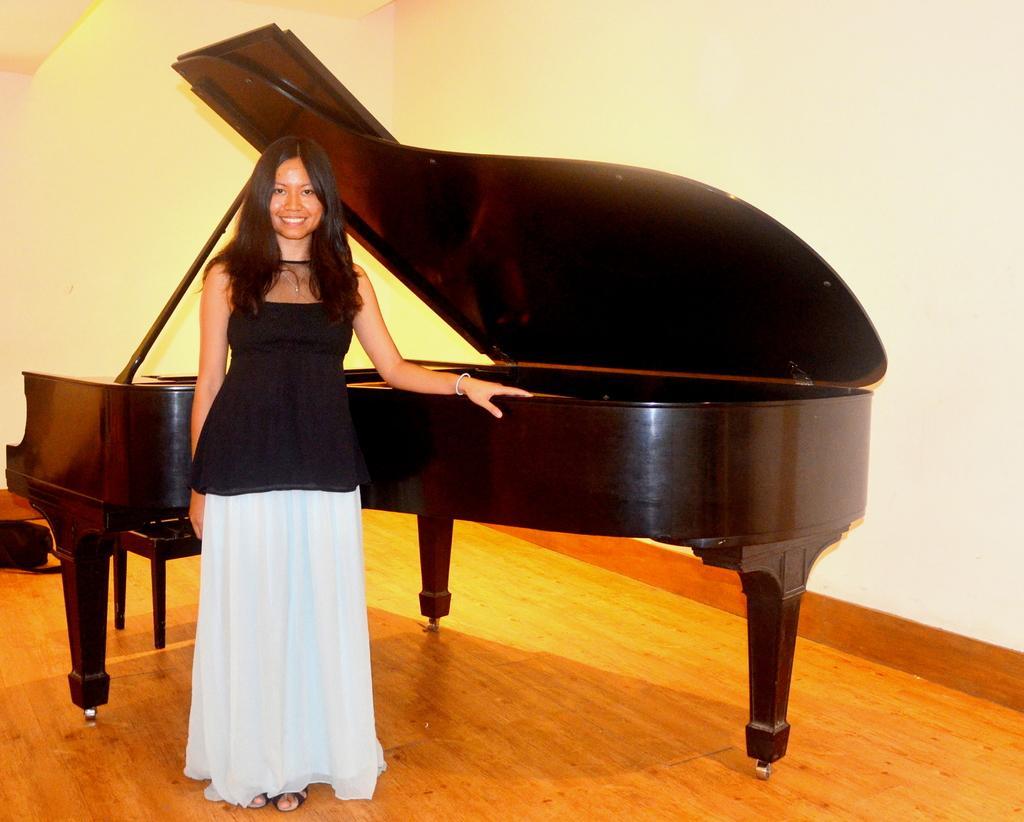Could you give a brief overview of what you see in this image? In this picture, there is a girl standing in front of a piano, placing her hand on it. In the background there is a wall and the girl is smiling. 